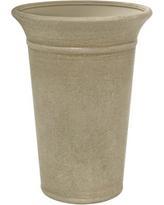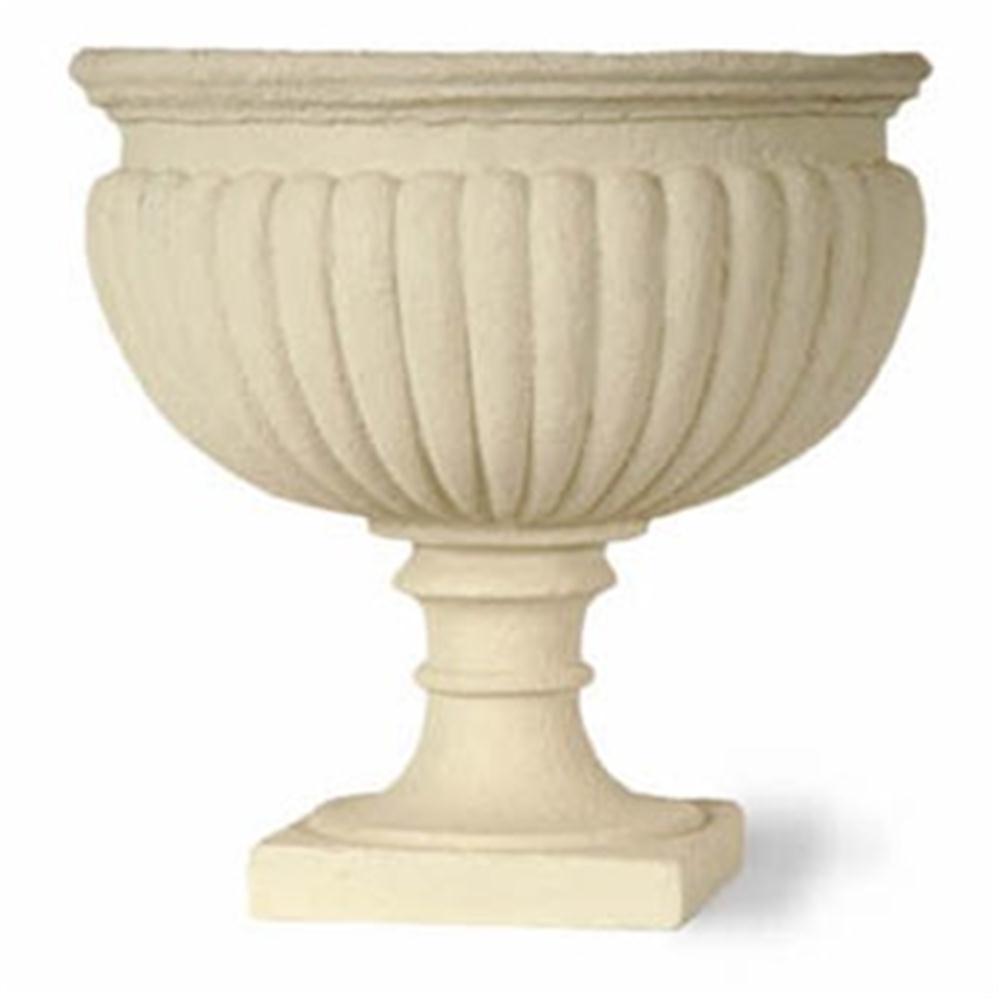The first image is the image on the left, the second image is the image on the right. Analyze the images presented: Is the assertion "Each image contains one empty urn, and one of the urn models is footed, with a pedestal base." valid? Answer yes or no. Yes. The first image is the image on the left, the second image is the image on the right. Evaluate the accuracy of this statement regarding the images: "In one image, a flowering plant is shown in a tall planter pot outside". Is it true? Answer yes or no. No. 